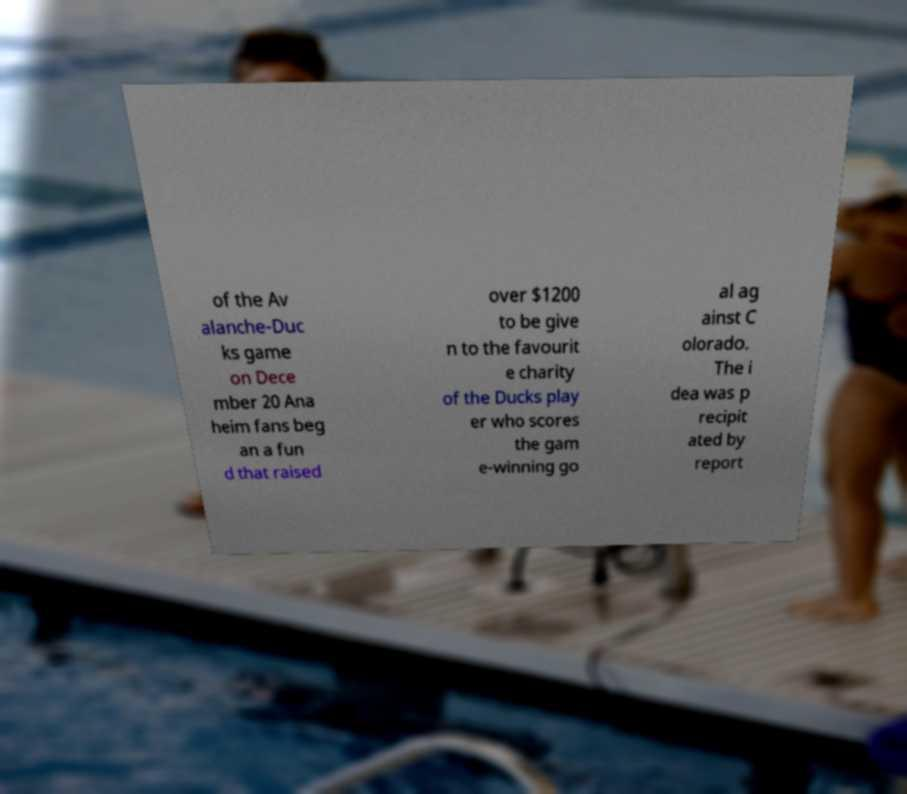What messages or text are displayed in this image? I need them in a readable, typed format. of the Av alanche-Duc ks game on Dece mber 20 Ana heim fans beg an a fun d that raised over $1200 to be give n to the favourit e charity of the Ducks play er who scores the gam e-winning go al ag ainst C olorado. The i dea was p recipit ated by report 